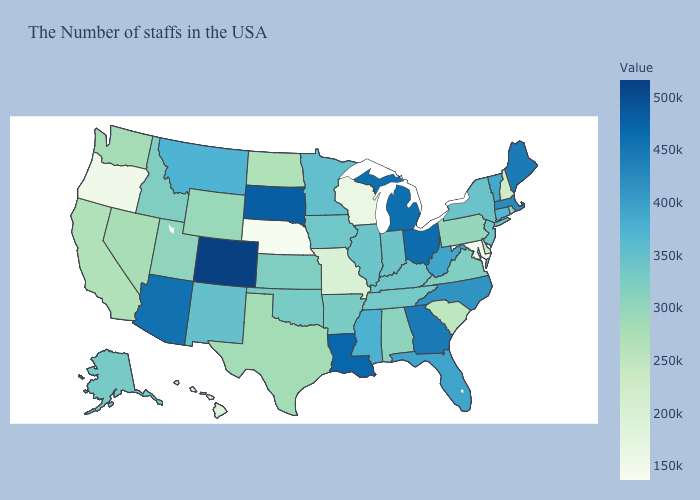Is the legend a continuous bar?
Give a very brief answer. Yes. Is the legend a continuous bar?
Short answer required. Yes. Among the states that border South Dakota , which have the lowest value?
Keep it brief. Nebraska. Does Nebraska have the lowest value in the USA?
Concise answer only. Yes. Does the map have missing data?
Concise answer only. No. Does the map have missing data?
Quick response, please. No. Is the legend a continuous bar?
Short answer required. Yes. Does Texas have a higher value than Wisconsin?
Answer briefly. Yes. 